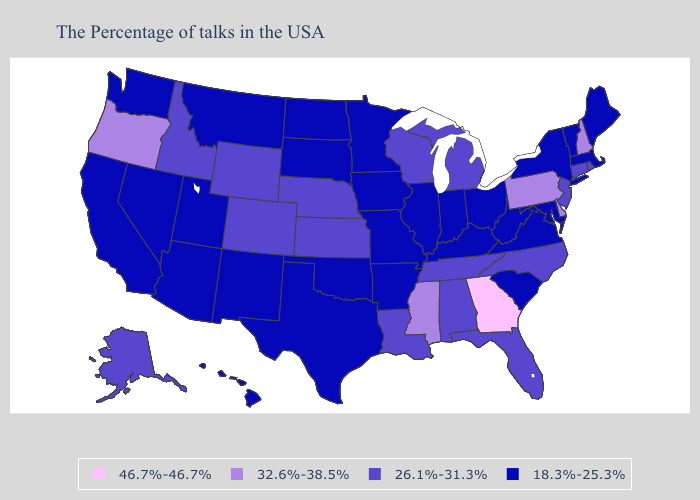What is the value of Mississippi?
Short answer required. 32.6%-38.5%. Name the states that have a value in the range 26.1%-31.3%?
Concise answer only. Rhode Island, Connecticut, New Jersey, North Carolina, Florida, Michigan, Alabama, Tennessee, Wisconsin, Louisiana, Kansas, Nebraska, Wyoming, Colorado, Idaho, Alaska. Among the states that border Kentucky , does Tennessee have the highest value?
Short answer required. Yes. Name the states that have a value in the range 46.7%-46.7%?
Concise answer only. Georgia. What is the highest value in the Northeast ?
Give a very brief answer. 32.6%-38.5%. What is the value of Arizona?
Concise answer only. 18.3%-25.3%. Does New York have the lowest value in the Northeast?
Give a very brief answer. Yes. Does Mississippi have the lowest value in the South?
Concise answer only. No. Which states have the lowest value in the MidWest?
Be succinct. Ohio, Indiana, Illinois, Missouri, Minnesota, Iowa, South Dakota, North Dakota. Does Georgia have the highest value in the USA?
Concise answer only. Yes. Name the states that have a value in the range 18.3%-25.3%?
Short answer required. Maine, Massachusetts, Vermont, New York, Maryland, Virginia, South Carolina, West Virginia, Ohio, Kentucky, Indiana, Illinois, Missouri, Arkansas, Minnesota, Iowa, Oklahoma, Texas, South Dakota, North Dakota, New Mexico, Utah, Montana, Arizona, Nevada, California, Washington, Hawaii. What is the value of Virginia?
Concise answer only. 18.3%-25.3%. Name the states that have a value in the range 32.6%-38.5%?
Quick response, please. New Hampshire, Delaware, Pennsylvania, Mississippi, Oregon. What is the highest value in the South ?
Give a very brief answer. 46.7%-46.7%. 